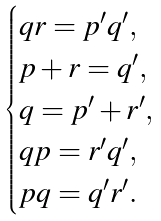Convert formula to latex. <formula><loc_0><loc_0><loc_500><loc_500>\begin{cases} q r = p ^ { \prime } q ^ { \prime } , \\ p + r = q ^ { \prime } , \\ q = p ^ { \prime } + r ^ { \prime } , \\ q p = r ^ { \prime } q ^ { \prime } , \\ p q = q ^ { \prime } r ^ { \prime } . \end{cases}</formula> 